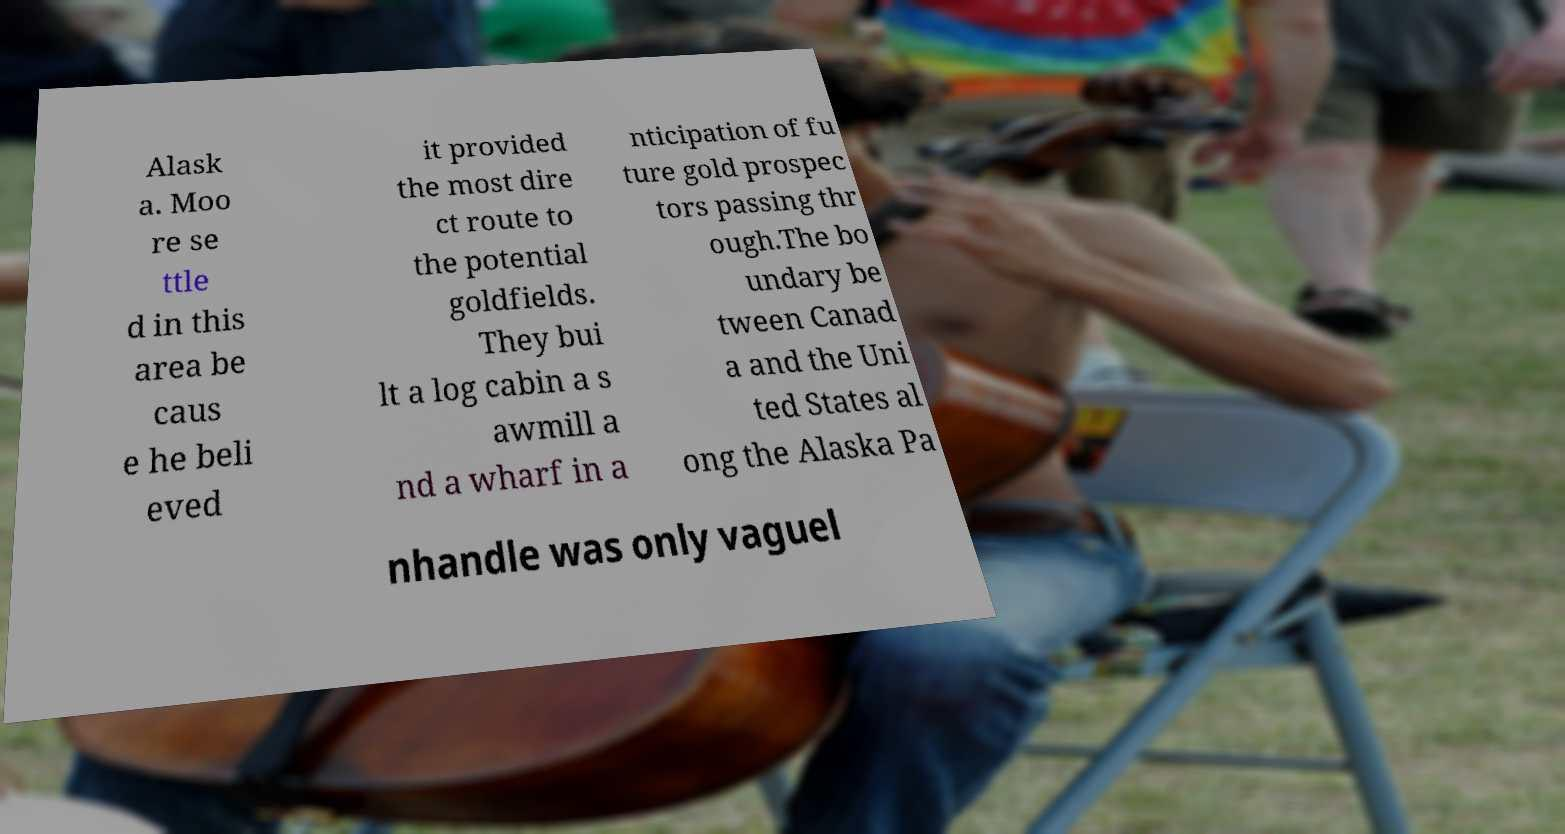Could you assist in decoding the text presented in this image and type it out clearly? Alask a. Moo re se ttle d in this area be caus e he beli eved it provided the most dire ct route to the potential goldfields. They bui lt a log cabin a s awmill a nd a wharf in a nticipation of fu ture gold prospec tors passing thr ough.The bo undary be tween Canad a and the Uni ted States al ong the Alaska Pa nhandle was only vaguel 